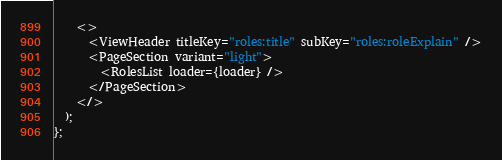<code> <loc_0><loc_0><loc_500><loc_500><_TypeScript_>    <>
      <ViewHeader titleKey="roles:title" subKey="roles:roleExplain" />
      <PageSection variant="light">
        <RolesList loader={loader} />
      </PageSection>
    </>
  );
};
</code> 